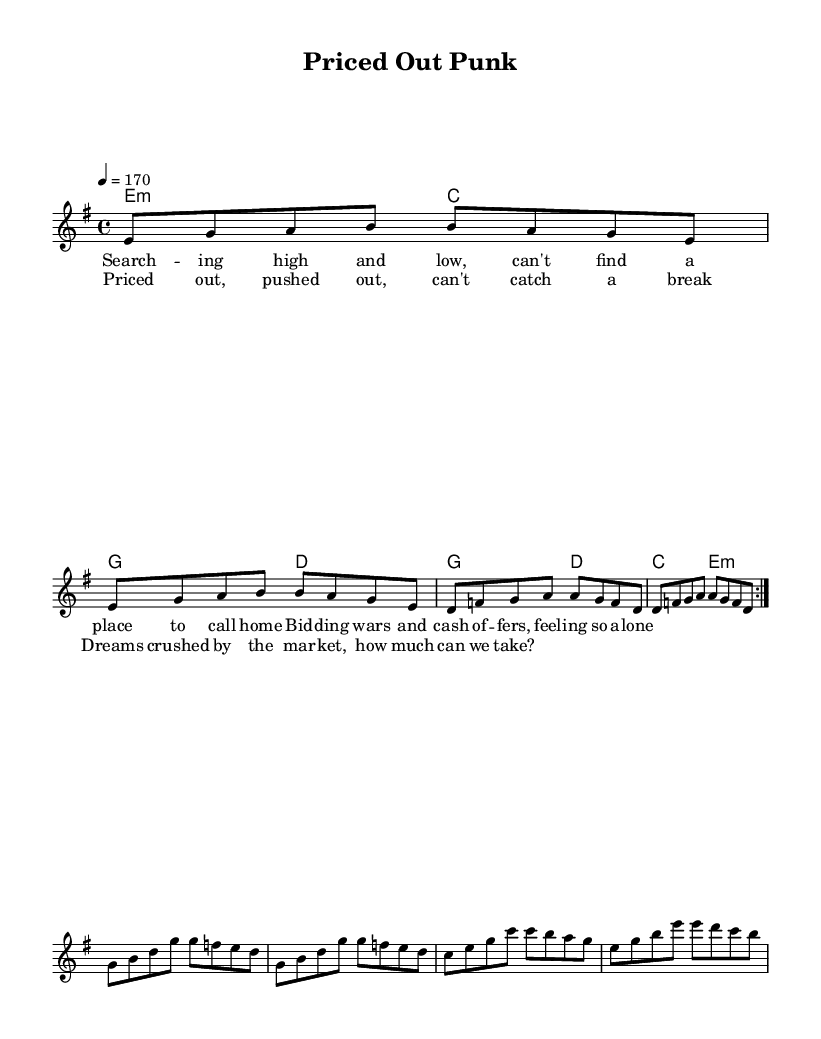What is the key signature of this music? The key signature is E minor, which has one sharp (F#). This is indicated at the beginning of the staff.
Answer: E minor What is the time signature of this music? The time signature is 4/4, which means there are four beats in each measure and the quarter note gets one beat. This is shown at the beginning of the score.
Answer: 4/4 What is the tempo marking for this piece? The tempo marking is 170 beats per minute, indicated by "4 = 170" at the beginning. This gives an energetic feel typical of punk music.
Answer: 170 How many measures are in the verse? The verse consists of eight measures, as shown by the two repetitions indicated in the score and the layout of the melody.
Answer: 8 What is the primary theme reflected in the lyrics? The primary theme reflects the struggle of first-time homebuyers in a competitive market, highlighted by phrases such as "bidding wars" and "priced out." The lyrics are specific to the challenges of finding a home.
Answer: Struggle of first-time homebuyers Which chord appears first in the harmonies? The first chord in the harmonies is E minor, marked as "e2:m," indicating the use of the minor chord related to the key signature.
Answer: E minor How does the chorus differ from the verse in terms of energy? The chorus is more intense and driving, which is common in punk music, typically reflecting heightened emotions or frustrations compared to the steadier verse. The rhythm and melody incorporate a more aggressive style, enhancing the core message.
Answer: More intense 